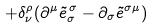Convert formula to latex. <formula><loc_0><loc_0><loc_500><loc_500>+ \delta _ { \nu } ^ { \rho } ( \partial ^ { \mu } \tilde { e } _ { \sigma } ^ { \, \sigma } - \partial _ { \sigma } \tilde { e } ^ { \sigma \mu } )</formula> 